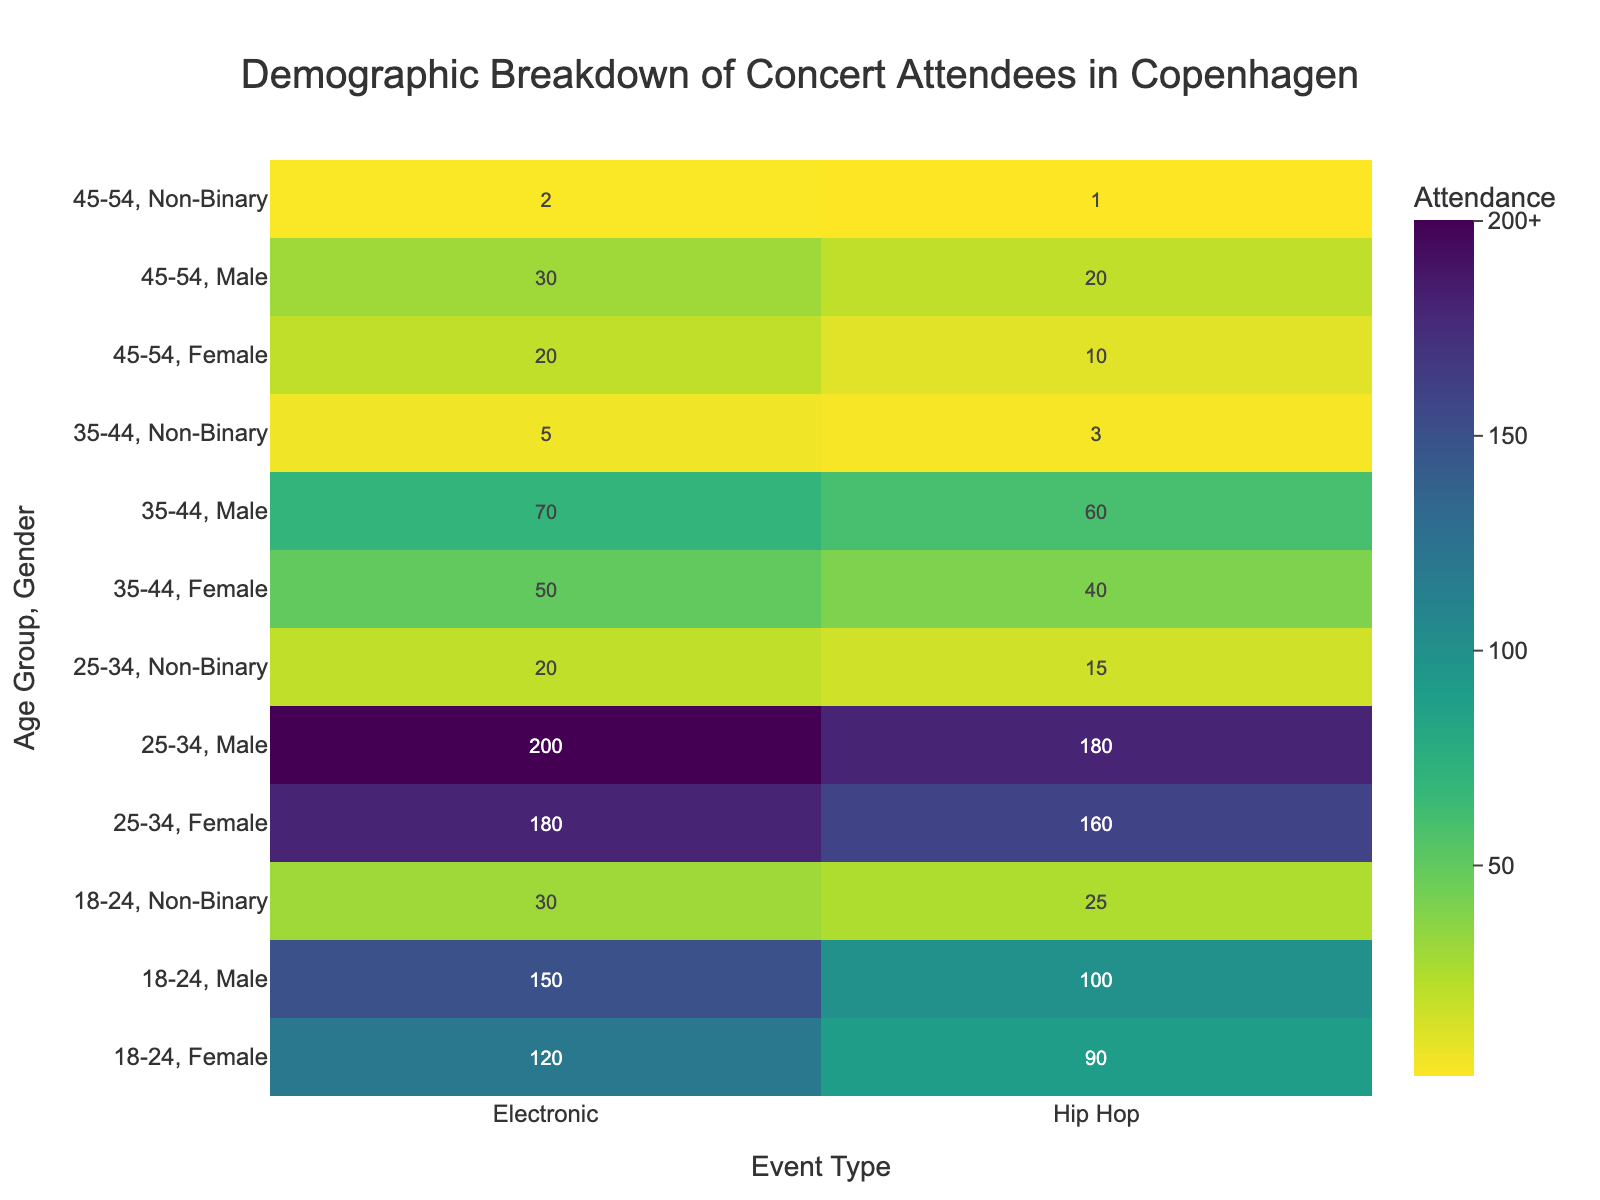What is the title of the heatmap? The title of the heatmap can be found at the top of the figure.
Answer: Demographic Breakdown of Concert Attendees in Copenhagen Which age group and gender have the lowest attendance for Hip Hop events? To find the lowest attendance, look at the values in the Hip Hop column and identify the smallest number.
Answer: 45-54, Non-Binary What is the total attendance for Electronic events in the 25-34 age group? Sum the attendance values for Electronic events in the 25-34 age group across all genders: 200 (Male) + 180 (Female) + 20 (Non-Binary).
Answer: 400 Which event type has the highest overall attendance in the 18-24 age group? Compare the attendance values for Electronic and Hip Hop events in the 18-24 age group across all genders to find the highest total: 150 (Male) + 120 (Female) + 30 (Non-Binary) for Electronic vs. 100 (Male) + 90 (Female) + 25 (Non-Binary) for Hip Hop.
Answer: Electronic What is the attendance difference between male and female attendees for Hip Hop events in the 25-34 age group? Subtract the female attendance from the male attendance for Hip Hop events in the 25-34 age group: 180 (Male) - 160 (Female).
Answer: 20 Which age group has the highest attendance for Electronic events, and what is the attendance value? Find the age group with the highest attendance value in the Electronic column by comparing values across age groups.
Answer: 25-34, 400 How does the attendance of Non-Binary attendees for Hip Hop events in the 35-44 age group compare to those in the 45-54 age group? Compare the attendance values for Non-Binary attendees in Hip Hop events between the two age groups: 3 (35-44) vs. 1 (45-54).
Answer: 35-44 has higher attendance What is the average attendance for Female attendees across all age groups for Electronic events? Calculate the average by summing the attendance values for Female attendees across all age groups for Electronic events, then divide by the number of age groups: (120 + 180 + 50 + 20) / 4.
Answer: 92.5 What is the overall total attendance for the 35-44 age group across both event types? Sum all the attendance values in the 35-44 age group for both Electronic and Hip Hop events: 70 (Male, Electronic) + 50 (Female, Electronic) + 5 (Non-Binary, Electronic) + 60 (Male, Hip Hop) + 40 (Female, Hip Hop) + 3 (Non-Binary, Hip Hop).
Answer: 228 